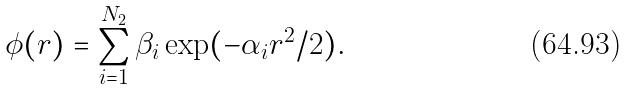Convert formula to latex. <formula><loc_0><loc_0><loc_500><loc_500>\phi ( r ) = \sum ^ { N _ { 2 } } _ { i = 1 } \beta _ { i } \exp ( - \alpha _ { i } r ^ { 2 } / 2 ) .</formula> 